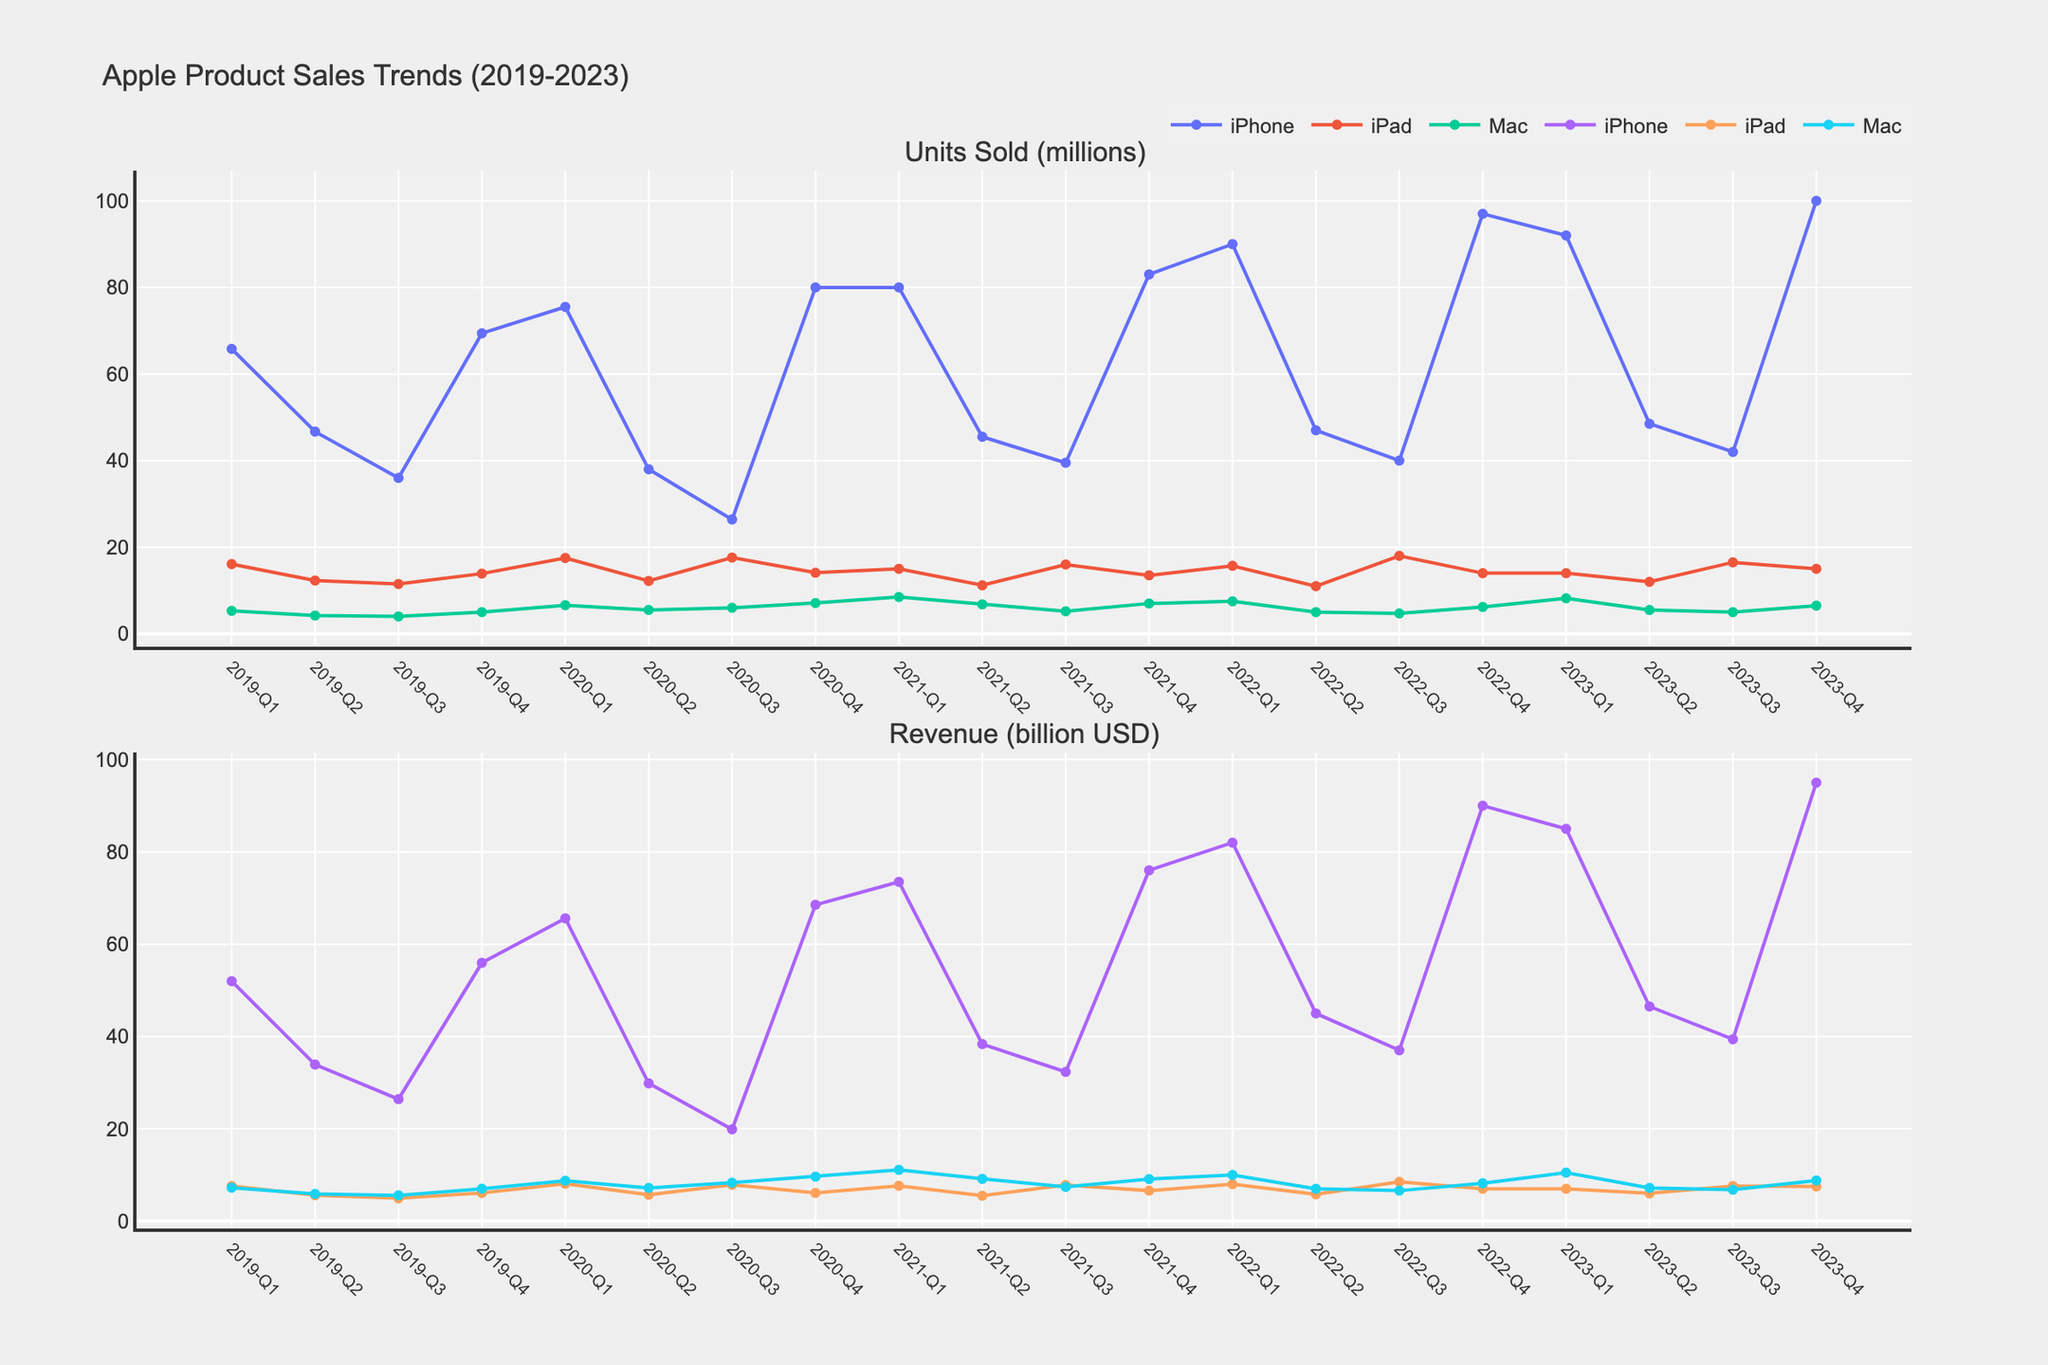What was the total units sold for iPhones in 2022? Adding all the quarterly units sold for iPhones in 2022, we have: 90.0 + 47.0 + 40.0 + 97.0 = 274.0 million units.
Answer: 274.0 million units Which quarter in 2023 had the highest revenue for the iPhone? Looking at the quarterly revenue data for iPhones in 2023, we see Q4 had the highest revenue of 95.00 billion USD compared to 85.00 billion USD in Q1, 46.50 billion USD in Q2, and 39.40 billion USD in Q3.
Answer: Q4 What was the percentage increase in Mac sales from Q1 2022 to Q1 2023 in terms of units sold? For Q1 2022, Mac units sold was 7.5 million, and for Q1 2023 it was 8.2 million. The increase is (8.2 - 7.5) / 7.5 * 100 = 9.33%.
Answer: 9.33% Did the iPad sales decrease in Q3 2021 compared to Q2 2021? Comparing Q2 2021 sales of 11.2 million to Q3 2021 sales of 16.0 million, we see an increase, so the statement is false.
Answer: No What is the total revenue generated from iPads in 2020? Summing up all quarterly revenues for iPads in 2020: 8.10 + 5.70 + 7.86 + 6.10 = 27.76 billion USD.
Answer: 27.76 billion USD Which product had the highest units sold in Q4 2022? In Q4 2022, the iPhone sold 97.0 million units, the iPad sold 14.0 million units, and the Mac sold 6.2 million units. Clearly, the iPhone had the highest sales.
Answer: iPhone What was the average revenue per quarter for Macs in 2019? The total revenue for Macs in 2019 was 7.24 + 5.89 + 5.58 + 7.01 = 25.72 billion USD. Dividing by 4 (the number of quarters) gives an average of 25.72 / 4 = 6.43 billion USD.
Answer: 6.43 billion USD Was there any decline in iPhone sales from Q1 2020 to Q3 2020? Comparing Q1 2020 units sold of 75.5 million to Q3 2020 units sold of 26.4 million, there is a clear decline.
Answer: Yes What was the total units sold for all products combined in Q2 2021? In Q2 2021, the total units sold were iPhone: 45.5 + iPad: 11.2 + Mac: 6.8 = 63.5 million units total.
Answer: 63.5 million units 